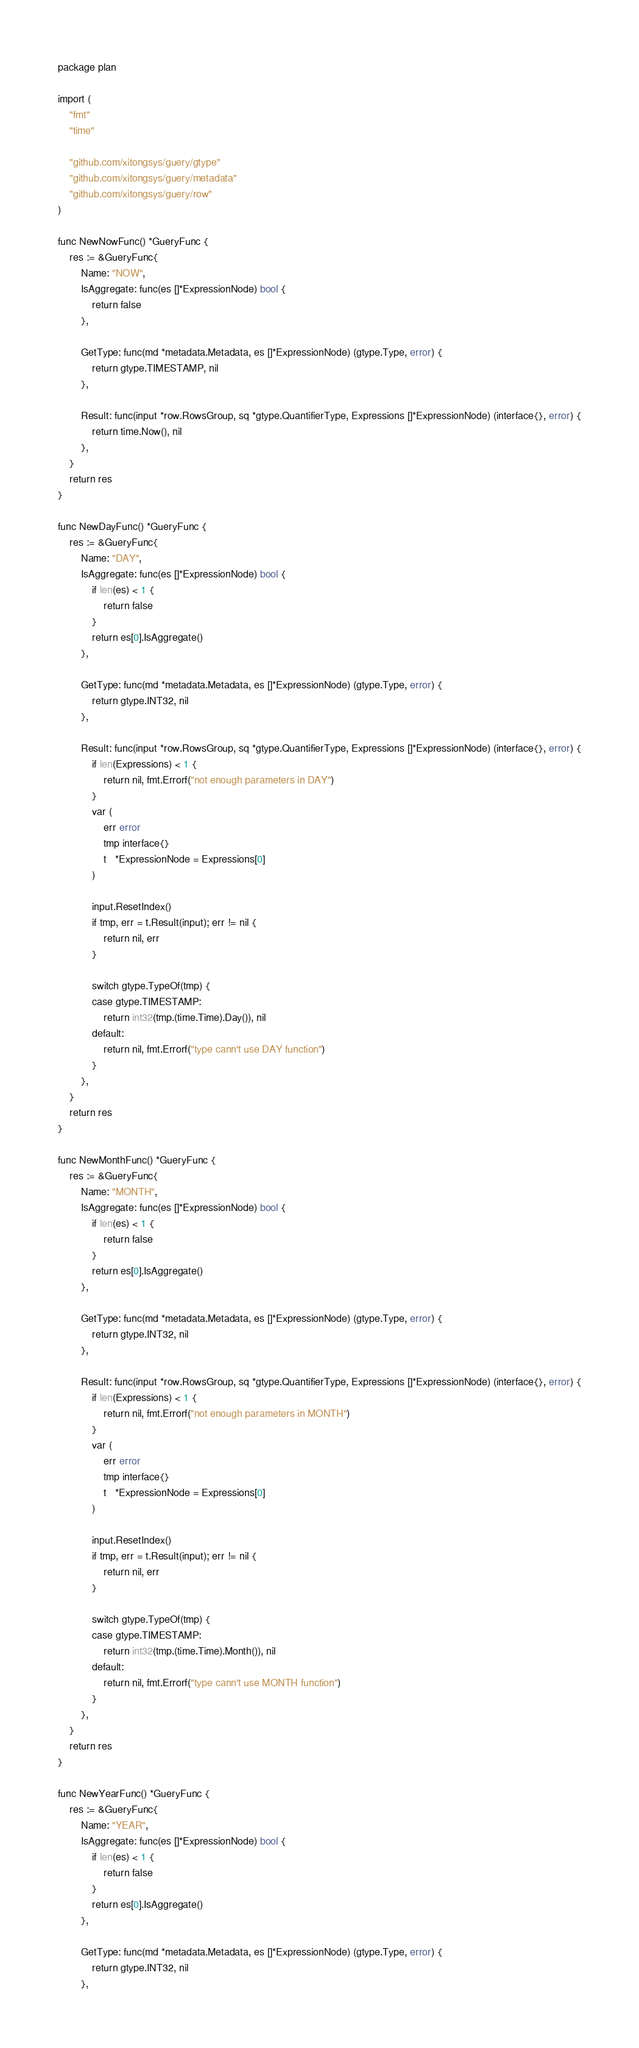<code> <loc_0><loc_0><loc_500><loc_500><_Go_>package plan

import (
	"fmt"
	"time"

	"github.com/xitongsys/guery/gtype"
	"github.com/xitongsys/guery/metadata"
	"github.com/xitongsys/guery/row"
)

func NewNowFunc() *GueryFunc {
	res := &GueryFunc{
		Name: "NOW",
		IsAggregate: func(es []*ExpressionNode) bool {
			return false
		},

		GetType: func(md *metadata.Metadata, es []*ExpressionNode) (gtype.Type, error) {
			return gtype.TIMESTAMP, nil
		},

		Result: func(input *row.RowsGroup, sq *gtype.QuantifierType, Expressions []*ExpressionNode) (interface{}, error) {
			return time.Now(), nil
		},
	}
	return res
}

func NewDayFunc() *GueryFunc {
	res := &GueryFunc{
		Name: "DAY",
		IsAggregate: func(es []*ExpressionNode) bool {
			if len(es) < 1 {
				return false
			}
			return es[0].IsAggregate()
		},

		GetType: func(md *metadata.Metadata, es []*ExpressionNode) (gtype.Type, error) {
			return gtype.INT32, nil
		},

		Result: func(input *row.RowsGroup, sq *gtype.QuantifierType, Expressions []*ExpressionNode) (interface{}, error) {
			if len(Expressions) < 1 {
				return nil, fmt.Errorf("not enough parameters in DAY")
			}
			var (
				err error
				tmp interface{}
				t   *ExpressionNode = Expressions[0]
			)

			input.ResetIndex()
			if tmp, err = t.Result(input); err != nil {
				return nil, err
			}

			switch gtype.TypeOf(tmp) {
			case gtype.TIMESTAMP:
				return int32(tmp.(time.Time).Day()), nil
			default:
				return nil, fmt.Errorf("type cann't use DAY function")
			}
		},
	}
	return res
}

func NewMonthFunc() *GueryFunc {
	res := &GueryFunc{
		Name: "MONTH",
		IsAggregate: func(es []*ExpressionNode) bool {
			if len(es) < 1 {
				return false
			}
			return es[0].IsAggregate()
		},

		GetType: func(md *metadata.Metadata, es []*ExpressionNode) (gtype.Type, error) {
			return gtype.INT32, nil
		},

		Result: func(input *row.RowsGroup, sq *gtype.QuantifierType, Expressions []*ExpressionNode) (interface{}, error) {
			if len(Expressions) < 1 {
				return nil, fmt.Errorf("not enough parameters in MONTH")
			}
			var (
				err error
				tmp interface{}
				t   *ExpressionNode = Expressions[0]
			)

			input.ResetIndex()
			if tmp, err = t.Result(input); err != nil {
				return nil, err
			}

			switch gtype.TypeOf(tmp) {
			case gtype.TIMESTAMP:
				return int32(tmp.(time.Time).Month()), nil
			default:
				return nil, fmt.Errorf("type cann't use MONTH function")
			}
		},
	}
	return res
}

func NewYearFunc() *GueryFunc {
	res := &GueryFunc{
		Name: "YEAR",
		IsAggregate: func(es []*ExpressionNode) bool {
			if len(es) < 1 {
				return false
			}
			return es[0].IsAggregate()
		},

		GetType: func(md *metadata.Metadata, es []*ExpressionNode) (gtype.Type, error) {
			return gtype.INT32, nil
		},
</code> 